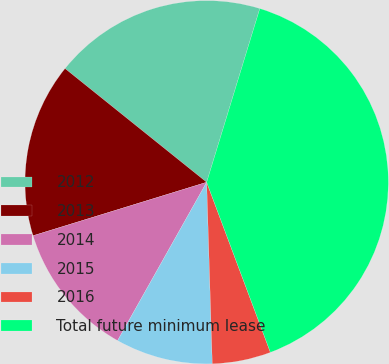Convert chart to OTSL. <chart><loc_0><loc_0><loc_500><loc_500><pie_chart><fcel>2012<fcel>2013<fcel>2014<fcel>2015<fcel>2016<fcel>Total future minimum lease<nl><fcel>18.96%<fcel>15.52%<fcel>12.09%<fcel>8.65%<fcel>5.21%<fcel>39.57%<nl></chart> 